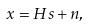<formula> <loc_0><loc_0><loc_500><loc_500>x = H s + n ,</formula> 